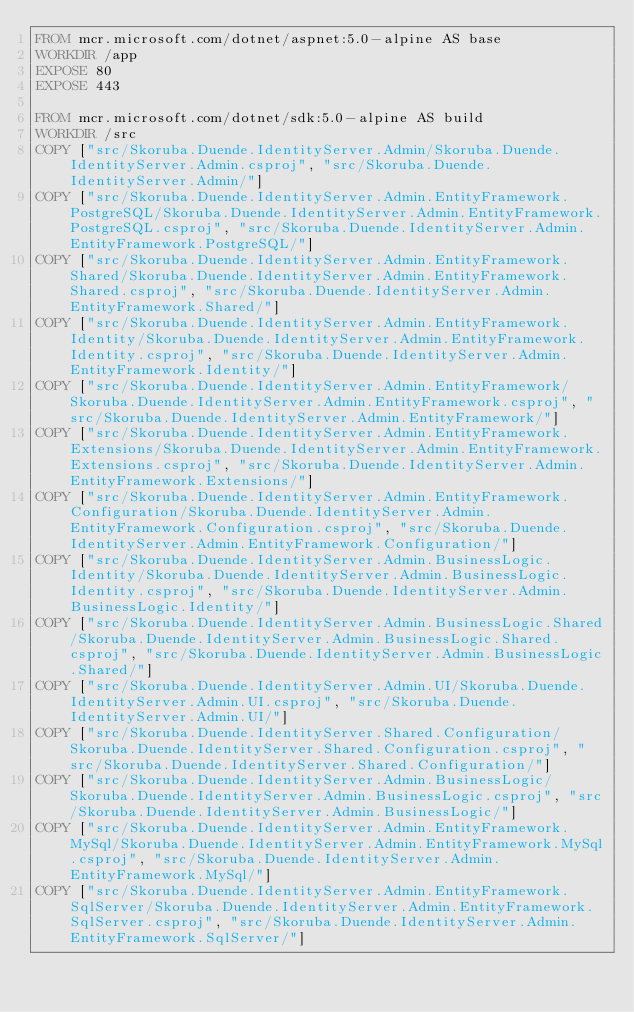<code> <loc_0><loc_0><loc_500><loc_500><_Dockerfile_>FROM mcr.microsoft.com/dotnet/aspnet:5.0-alpine AS base
WORKDIR /app
EXPOSE 80
EXPOSE 443

FROM mcr.microsoft.com/dotnet/sdk:5.0-alpine AS build
WORKDIR /src
COPY ["src/Skoruba.Duende.IdentityServer.Admin/Skoruba.Duende.IdentityServer.Admin.csproj", "src/Skoruba.Duende.IdentityServer.Admin/"]
COPY ["src/Skoruba.Duende.IdentityServer.Admin.EntityFramework.PostgreSQL/Skoruba.Duende.IdentityServer.Admin.EntityFramework.PostgreSQL.csproj", "src/Skoruba.Duende.IdentityServer.Admin.EntityFramework.PostgreSQL/"]
COPY ["src/Skoruba.Duende.IdentityServer.Admin.EntityFramework.Shared/Skoruba.Duende.IdentityServer.Admin.EntityFramework.Shared.csproj", "src/Skoruba.Duende.IdentityServer.Admin.EntityFramework.Shared/"]
COPY ["src/Skoruba.Duende.IdentityServer.Admin.EntityFramework.Identity/Skoruba.Duende.IdentityServer.Admin.EntityFramework.Identity.csproj", "src/Skoruba.Duende.IdentityServer.Admin.EntityFramework.Identity/"]
COPY ["src/Skoruba.Duende.IdentityServer.Admin.EntityFramework/Skoruba.Duende.IdentityServer.Admin.EntityFramework.csproj", "src/Skoruba.Duende.IdentityServer.Admin.EntityFramework/"]
COPY ["src/Skoruba.Duende.IdentityServer.Admin.EntityFramework.Extensions/Skoruba.Duende.IdentityServer.Admin.EntityFramework.Extensions.csproj", "src/Skoruba.Duende.IdentityServer.Admin.EntityFramework.Extensions/"]
COPY ["src/Skoruba.Duende.IdentityServer.Admin.EntityFramework.Configuration/Skoruba.Duende.IdentityServer.Admin.EntityFramework.Configuration.csproj", "src/Skoruba.Duende.IdentityServer.Admin.EntityFramework.Configuration/"]
COPY ["src/Skoruba.Duende.IdentityServer.Admin.BusinessLogic.Identity/Skoruba.Duende.IdentityServer.Admin.BusinessLogic.Identity.csproj", "src/Skoruba.Duende.IdentityServer.Admin.BusinessLogic.Identity/"]
COPY ["src/Skoruba.Duende.IdentityServer.Admin.BusinessLogic.Shared/Skoruba.Duende.IdentityServer.Admin.BusinessLogic.Shared.csproj", "src/Skoruba.Duende.IdentityServer.Admin.BusinessLogic.Shared/"]
COPY ["src/Skoruba.Duende.IdentityServer.Admin.UI/Skoruba.Duende.IdentityServer.Admin.UI.csproj", "src/Skoruba.Duende.IdentityServer.Admin.UI/"]
COPY ["src/Skoruba.Duende.IdentityServer.Shared.Configuration/Skoruba.Duende.IdentityServer.Shared.Configuration.csproj", "src/Skoruba.Duende.IdentityServer.Shared.Configuration/"]
COPY ["src/Skoruba.Duende.IdentityServer.Admin.BusinessLogic/Skoruba.Duende.IdentityServer.Admin.BusinessLogic.csproj", "src/Skoruba.Duende.IdentityServer.Admin.BusinessLogic/"]
COPY ["src/Skoruba.Duende.IdentityServer.Admin.EntityFramework.MySql/Skoruba.Duende.IdentityServer.Admin.EntityFramework.MySql.csproj", "src/Skoruba.Duende.IdentityServer.Admin.EntityFramework.MySql/"]
COPY ["src/Skoruba.Duende.IdentityServer.Admin.EntityFramework.SqlServer/Skoruba.Duende.IdentityServer.Admin.EntityFramework.SqlServer.csproj", "src/Skoruba.Duende.IdentityServer.Admin.EntityFramework.SqlServer/"]</code> 